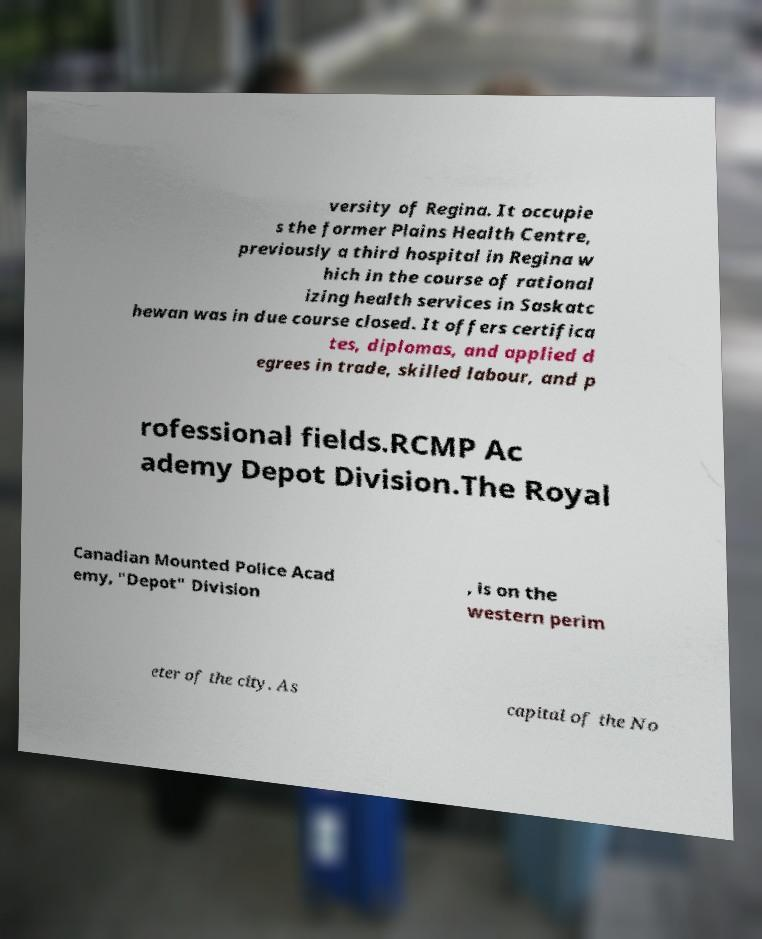There's text embedded in this image that I need extracted. Can you transcribe it verbatim? versity of Regina. It occupie s the former Plains Health Centre, previously a third hospital in Regina w hich in the course of rational izing health services in Saskatc hewan was in due course closed. It offers certifica tes, diplomas, and applied d egrees in trade, skilled labour, and p rofessional fields.RCMP Ac ademy Depot Division.The Royal Canadian Mounted Police Acad emy, "Depot" Division , is on the western perim eter of the city. As capital of the No 